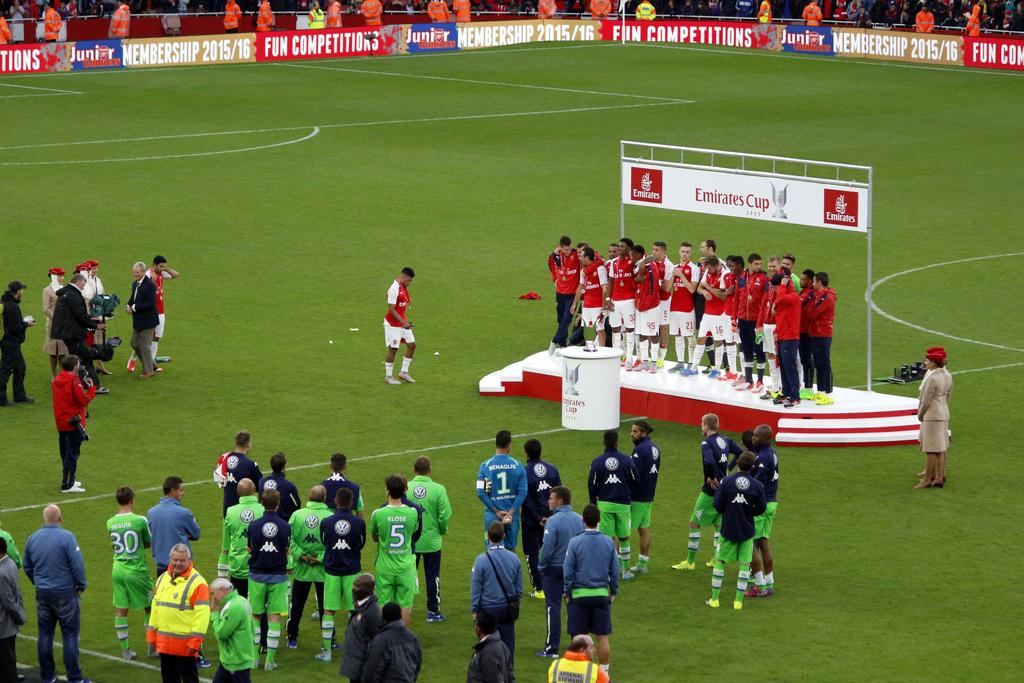<image>
Offer a succinct explanation of the picture presented. Arsenal football team are seen posing on the winners podium beneath a sign that says Emirates Cup. 